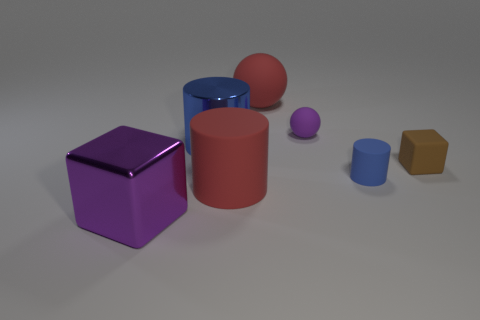There is a large shiny thing to the right of the purple object in front of the cube that is behind the big shiny cube; what is its color?
Give a very brief answer. Blue. The tiny thing that is both to the left of the tiny brown object and to the right of the small purple sphere has what shape?
Provide a short and direct response. Cylinder. There is a large rubber object that is left of the red object that is behind the tiny brown matte cube; what color is it?
Ensure brevity in your answer.  Red. What shape is the large metallic thing on the right side of the big metal cube that is to the left of the block on the right side of the purple block?
Your answer should be compact. Cylinder. There is a matte thing that is both right of the red ball and to the left of the tiny blue cylinder; what is its size?
Offer a very short reply. Small. How many big matte cylinders have the same color as the big sphere?
Ensure brevity in your answer.  1. There is a sphere that is the same color as the metal cube; what material is it?
Offer a terse response. Rubber. What is the tiny blue object made of?
Keep it short and to the point. Rubber. Does the big red object behind the tiny purple matte ball have the same material as the brown thing?
Offer a very short reply. Yes. There is a large red thing to the right of the red rubber cylinder; what is its shape?
Make the answer very short. Sphere. 